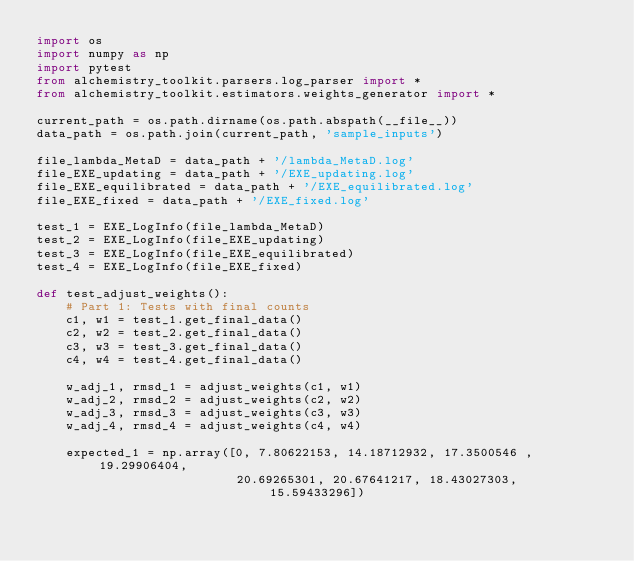<code> <loc_0><loc_0><loc_500><loc_500><_Python_>import os
import numpy as np
import pytest
from alchemistry_toolkit.parsers.log_parser import *
from alchemistry_toolkit.estimators.weights_generator import *

current_path = os.path.dirname(os.path.abspath(__file__))
data_path = os.path.join(current_path, 'sample_inputs')

file_lambda_MetaD = data_path + '/lambda_MetaD.log'
file_EXE_updating = data_path + '/EXE_updating.log'
file_EXE_equilibrated = data_path + '/EXE_equilibrated.log'
file_EXE_fixed = data_path + '/EXE_fixed.log'

test_1 = EXE_LogInfo(file_lambda_MetaD)
test_2 = EXE_LogInfo(file_EXE_updating)
test_3 = EXE_LogInfo(file_EXE_equilibrated)
test_4 = EXE_LogInfo(file_EXE_fixed)

def test_adjust_weights():
    # Part 1: Tests with final counts
    c1, w1 = test_1.get_final_data()
    c2, w2 = test_2.get_final_data()
    c3, w3 = test_3.get_final_data()
    c4, w4 = test_4.get_final_data()
    
    w_adj_1, rmsd_1 = adjust_weights(c1, w1)
    w_adj_2, rmsd_2 = adjust_weights(c2, w2)
    w_adj_3, rmsd_3 = adjust_weights(c3, w3)
    w_adj_4, rmsd_4 = adjust_weights(c4, w4)

    expected_1 = np.array([0, 7.80622153, 14.18712932, 17.3500546 , 19.29906404, 
                           20.69265301, 20.67641217, 18.43027303, 15.59433296])</code> 